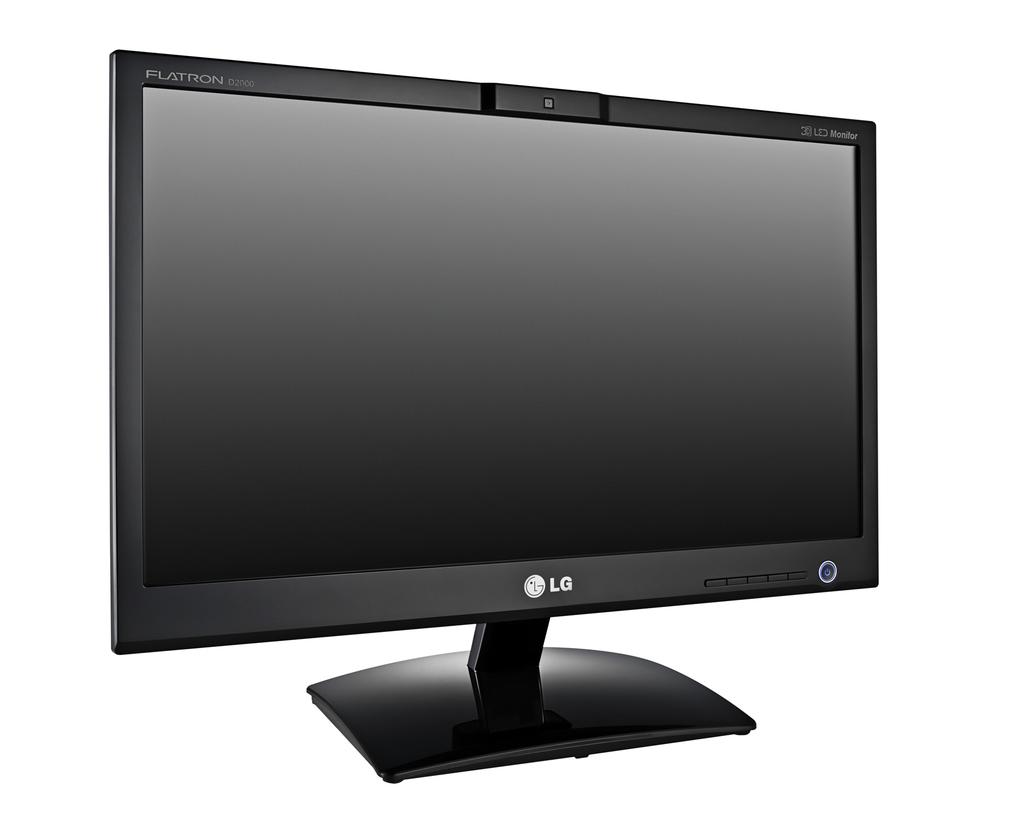What brand of monitor is this?
Keep it short and to the point. Lg. 